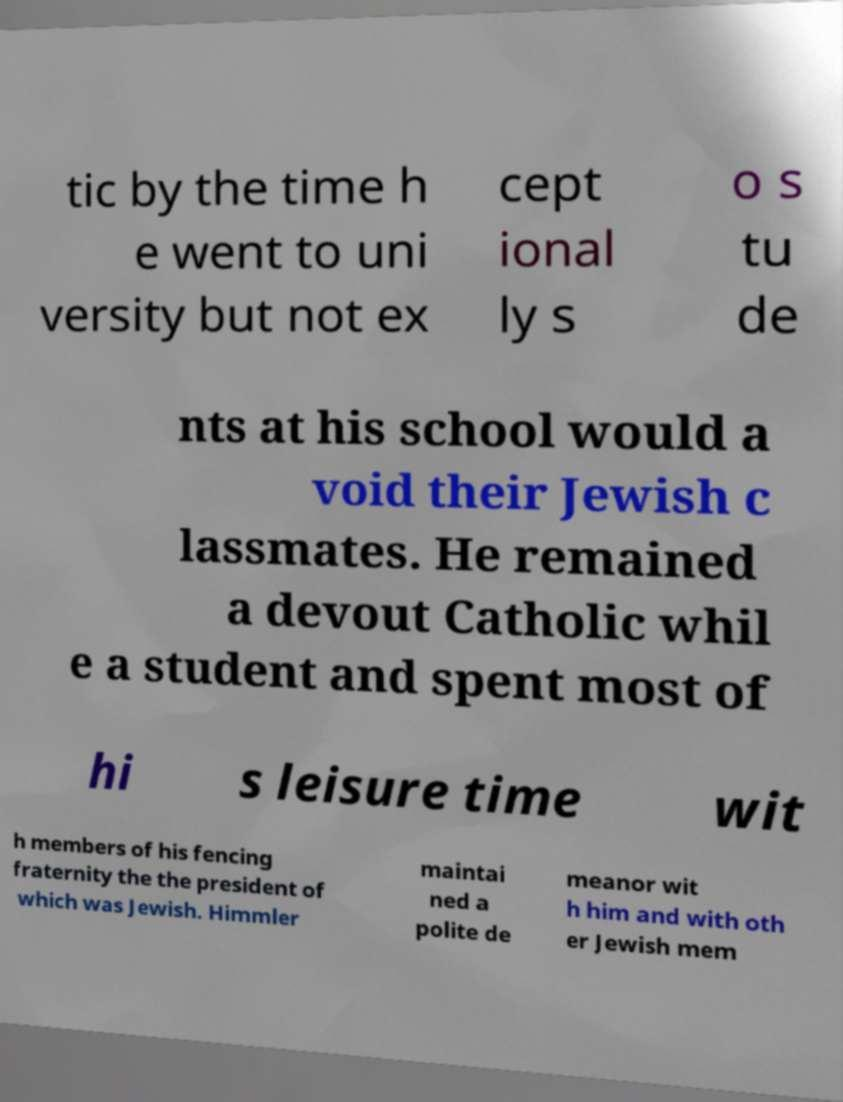Please identify and transcribe the text found in this image. tic by the time h e went to uni versity but not ex cept ional ly s o s tu de nts at his school would a void their Jewish c lassmates. He remained a devout Catholic whil e a student and spent most of hi s leisure time wit h members of his fencing fraternity the the president of which was Jewish. Himmler maintai ned a polite de meanor wit h him and with oth er Jewish mem 